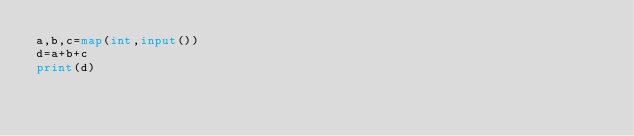<code> <loc_0><loc_0><loc_500><loc_500><_Python_>a,b,c=map(int,input())
d=a+b+c
print(d)</code> 